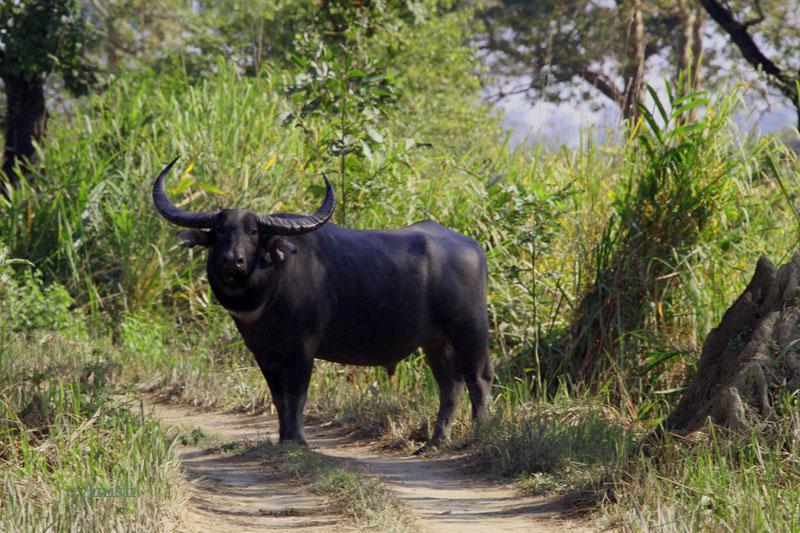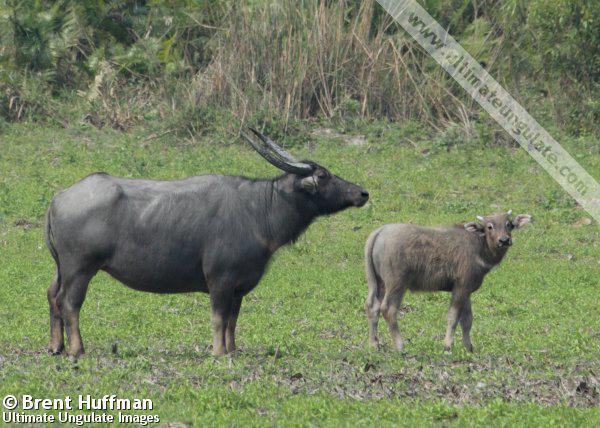The first image is the image on the left, the second image is the image on the right. For the images displayed, is the sentence "The right image contains no more than one water buffalo." factually correct? Answer yes or no. No. The first image is the image on the left, the second image is the image on the right. Considering the images on both sides, is "The righthand image shows exactly one water buffalo, which faces the camera." valid? Answer yes or no. No. 